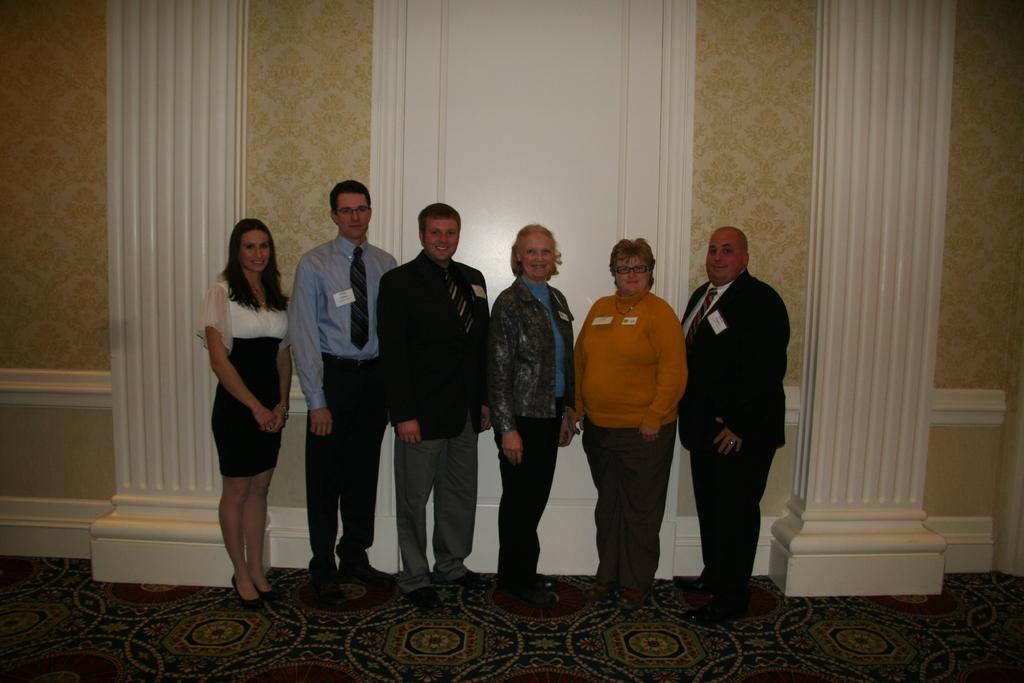How many people are present in the image? There are six people standing in the image. What are the people wearing? All the people are wearing clothes and shoes. Can you describe any accessories worn by the people? Two of the people are wearing spectacles. What is the general expression of the people in the image? The people are smiling. What type of surface is visible in the image? There is a floor visible in the image. What else can be seen in the background of the image? There is a wall visible in the image. What type of nut is being cracked by the people in the image? There is no nut present in the image, and the people are not performing any such action. Can you see any bubbles floating around the people in the image? There are no bubbles visible in the image. 